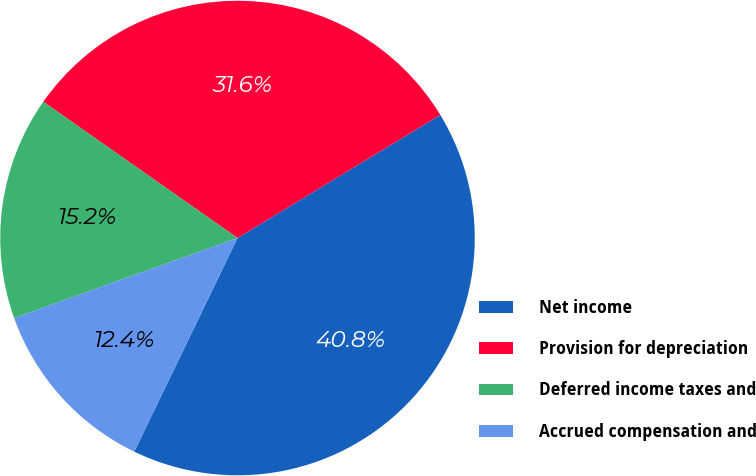Convert chart to OTSL. <chart><loc_0><loc_0><loc_500><loc_500><pie_chart><fcel>Net income<fcel>Provision for depreciation<fcel>Deferred income taxes and<fcel>Accrued compensation and<nl><fcel>40.85%<fcel>31.58%<fcel>15.21%<fcel>12.36%<nl></chart> 